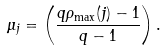<formula> <loc_0><loc_0><loc_500><loc_500>\mu _ { j } = \left ( \frac { q \rho _ { \max } ( j ) - 1 } { q - 1 } \right ) .</formula> 